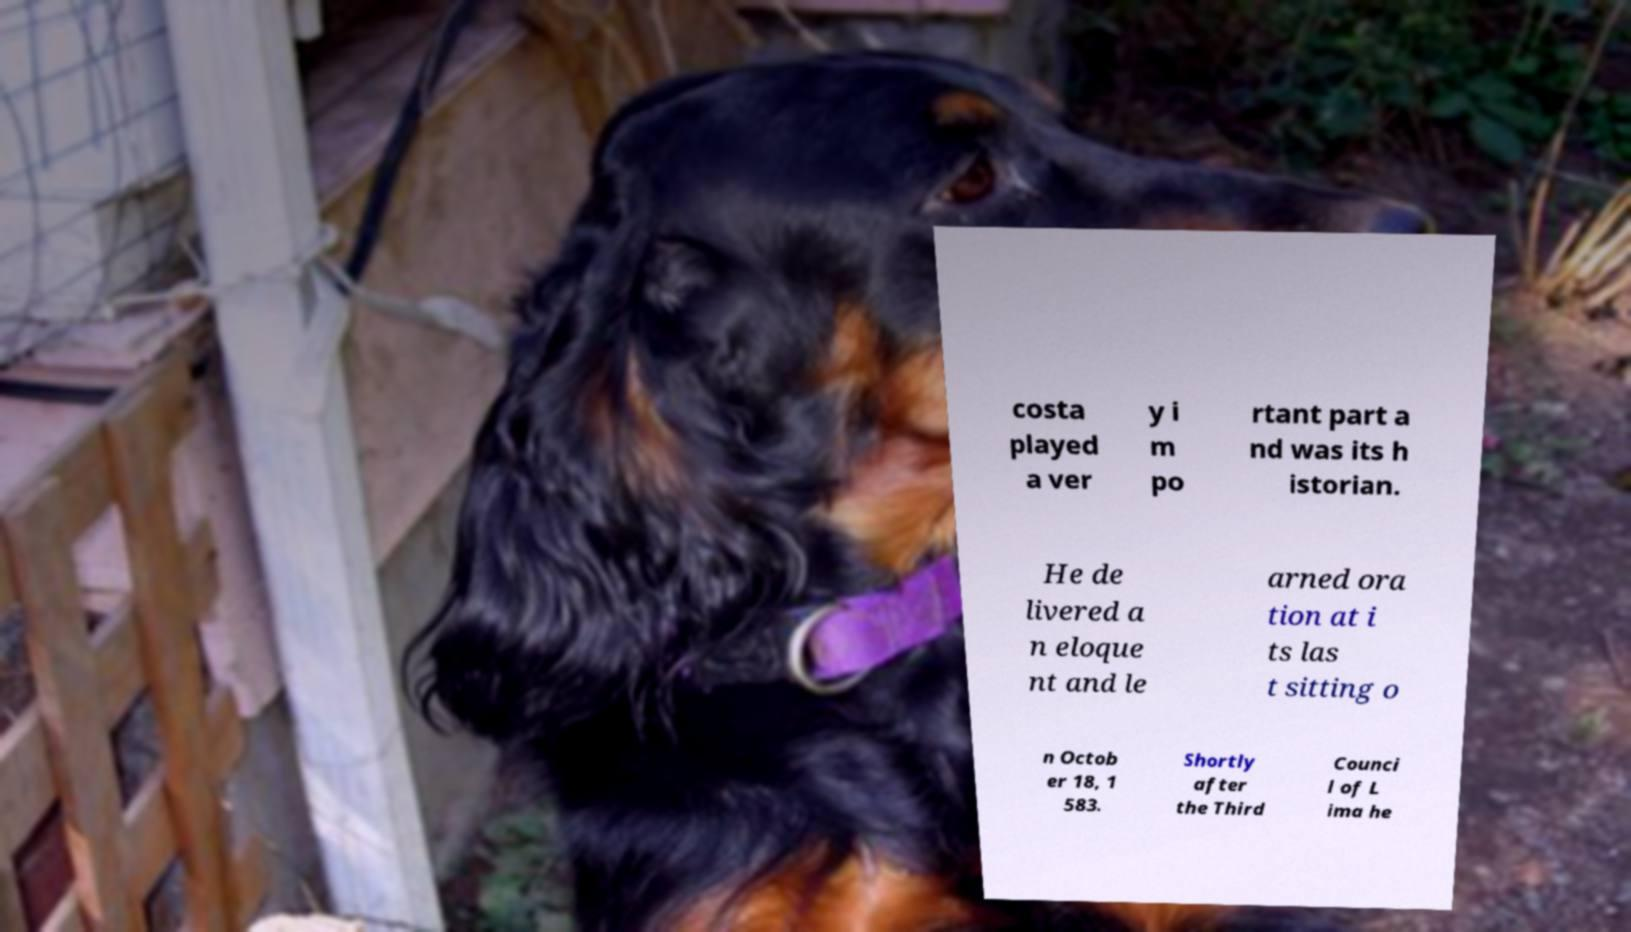There's text embedded in this image that I need extracted. Can you transcribe it verbatim? costa played a ver y i m po rtant part a nd was its h istorian. He de livered a n eloque nt and le arned ora tion at i ts las t sitting o n Octob er 18, 1 583. Shortly after the Third Counci l of L ima he 